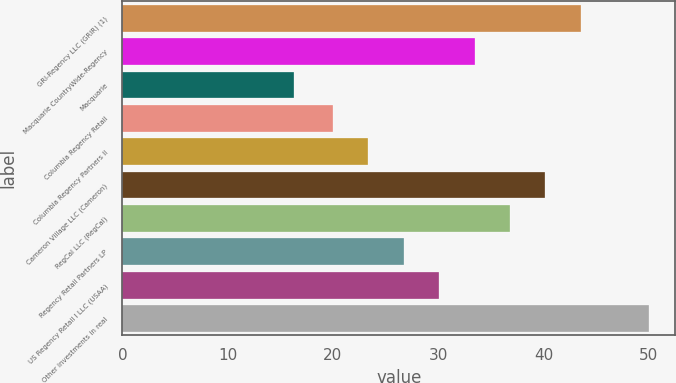<chart> <loc_0><loc_0><loc_500><loc_500><bar_chart><fcel>GRI-Regency LLC (GRIR) (1)<fcel>Macquarie CountryWide-Regency<fcel>Macquarie<fcel>Columbia Regency Retail<fcel>Columbia Regency Partners II<fcel>Cameron Village LLC (Cameron)<fcel>RegCal LLC (RegCal)<fcel>Regency Retail Partners LP<fcel>US Regency Retail I LLC (USAA)<fcel>Other investments in real<nl><fcel>43.55<fcel>33.45<fcel>16.35<fcel>20<fcel>23.37<fcel>40.19<fcel>36.82<fcel>26.73<fcel>30.09<fcel>50<nl></chart> 